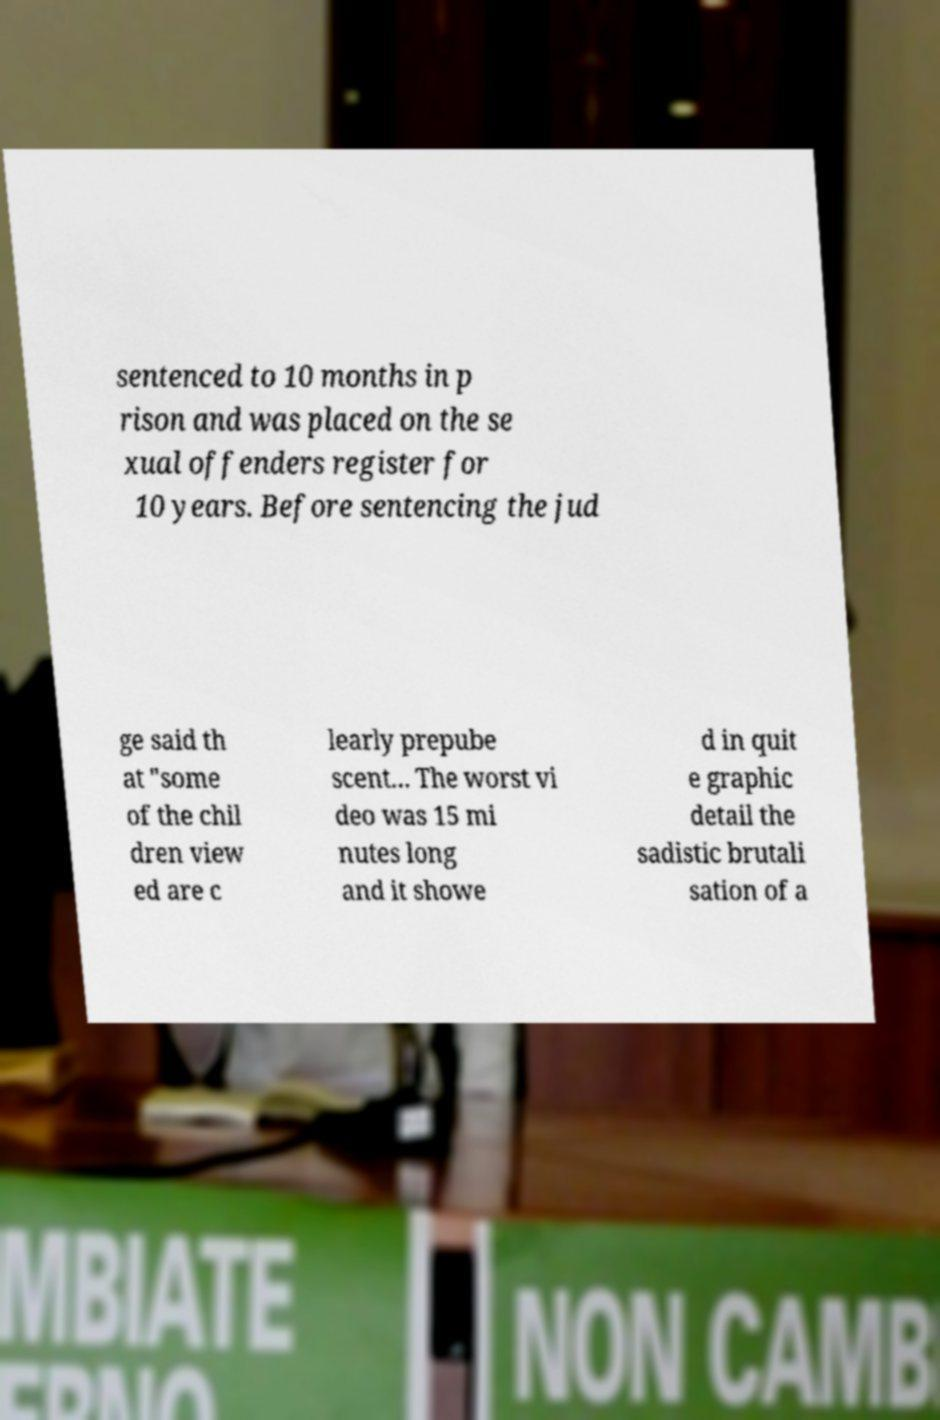What messages or text are displayed in this image? I need them in a readable, typed format. sentenced to 10 months in p rison and was placed on the se xual offenders register for 10 years. Before sentencing the jud ge said th at "some of the chil dren view ed are c learly prepube scent... The worst vi deo was 15 mi nutes long and it showe d in quit e graphic detail the sadistic brutali sation of a 